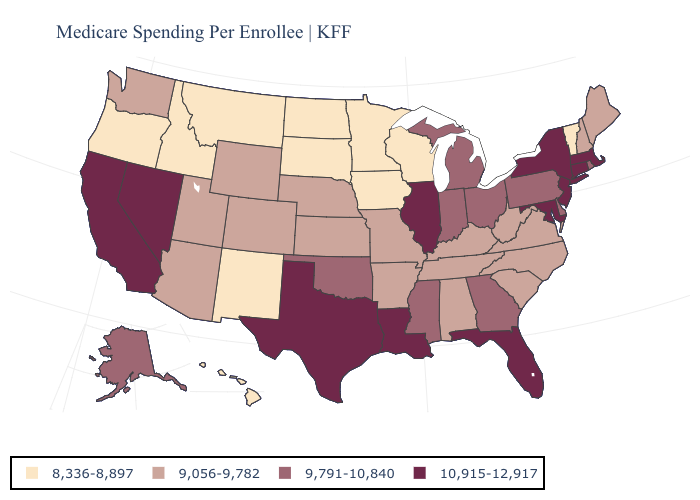Is the legend a continuous bar?
Concise answer only. No. How many symbols are there in the legend?
Give a very brief answer. 4. What is the highest value in states that border Montana?
Write a very short answer. 9,056-9,782. What is the lowest value in the USA?
Be succinct. 8,336-8,897. Does the map have missing data?
Answer briefly. No. Does Maine have a higher value than Arizona?
Short answer required. No. What is the value of Washington?
Answer briefly. 9,056-9,782. Name the states that have a value in the range 9,791-10,840?
Give a very brief answer. Alaska, Delaware, Georgia, Indiana, Michigan, Mississippi, Ohio, Oklahoma, Pennsylvania, Rhode Island. Among the states that border New York , does Pennsylvania have the highest value?
Short answer required. No. Is the legend a continuous bar?
Quick response, please. No. Which states have the lowest value in the South?
Keep it brief. Alabama, Arkansas, Kentucky, North Carolina, South Carolina, Tennessee, Virginia, West Virginia. Among the states that border Iowa , which have the lowest value?
Write a very short answer. Minnesota, South Dakota, Wisconsin. Among the states that border South Carolina , does Georgia have the lowest value?
Concise answer only. No. What is the value of Montana?
Quick response, please. 8,336-8,897. Does Louisiana have the same value as Texas?
Short answer required. Yes. 